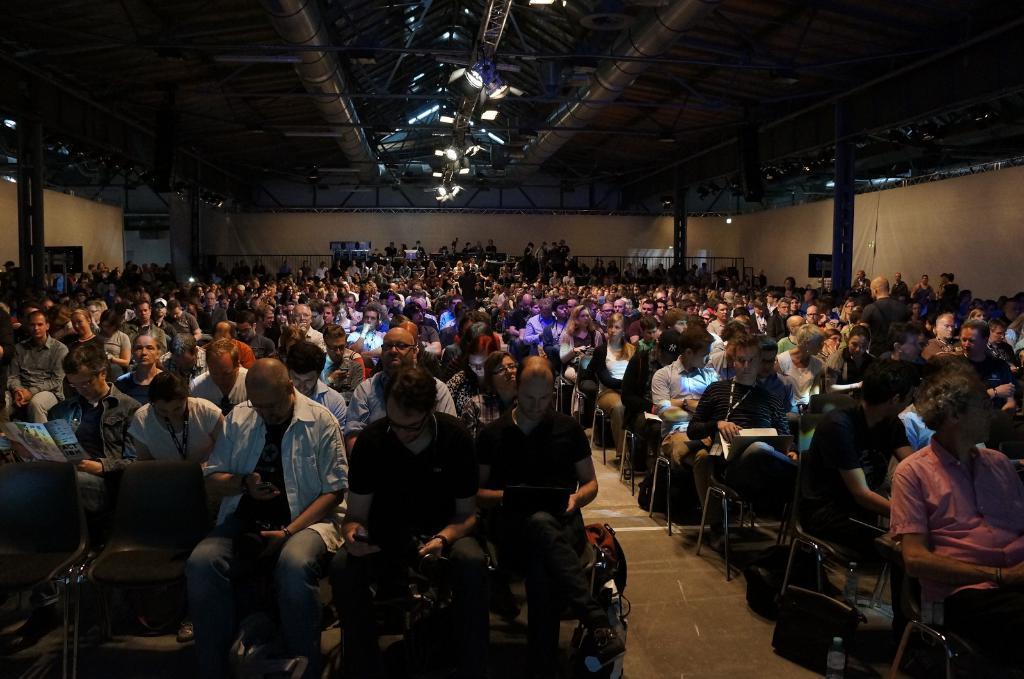Could you give a brief overview of what you see in this image? A group of people are sitting on the chairs, at the top there are focused lights to the roof. 